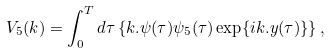Convert formula to latex. <formula><loc_0><loc_0><loc_500><loc_500>V _ { 5 } ( k ) = \int _ { 0 } ^ { T } d \tau \left \{ k . \psi ( \tau ) \psi _ { 5 } ( \tau ) \exp \{ i k . y ( \tau ) \} \right \} ,</formula> 